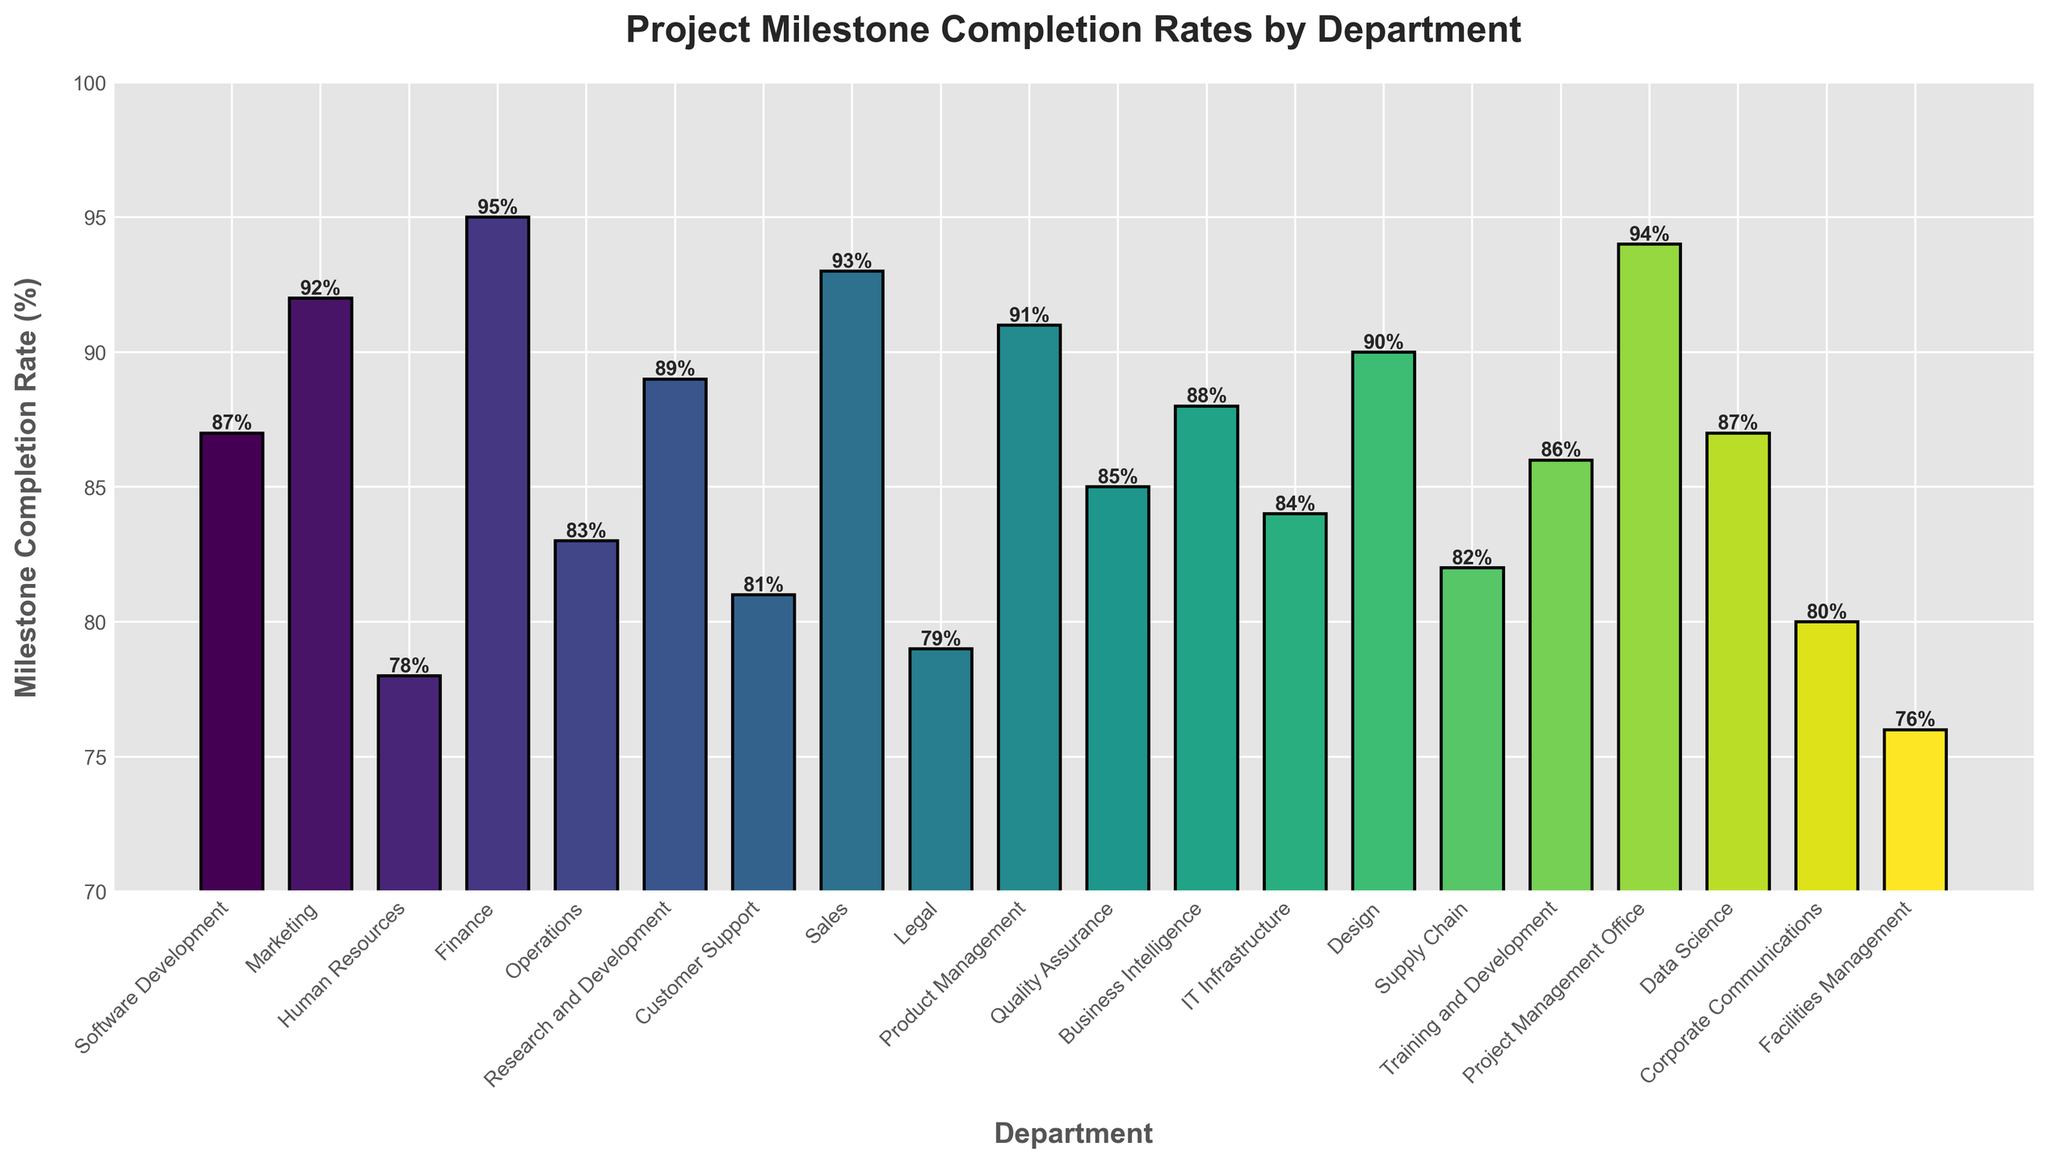What's the highest milestone completion rate? To determine the highest milestone completion rate, scan through all the bars and find the maximum value. The Finance department has the highest completion rate at 95%.
Answer: 95% Which departments have a milestone completion rate above 90%? Identify and list bars with a milestone completion rate greater than 90%. The departments are Marketing (92%), Finance (95%), Sales (93%), Product Management (91%), and Project Management Office (94%).
Answer: Marketing, Finance, Sales, Product Management, Project Management Office Which department has the lowest milestone completion rate, and what is it? To find the department with the lowest milestone completion rate, locate the shortest bar. Facilities Management has the lowest completion rate at 76%.
Answer: Facilities Management, 76% What's the average milestone completion rate across all departments? Add up the milestone completion rates for all departments and divide by the number of departments. (87+92+78+95+83+89+81+93+79+91+85+88+84+90+82+86+94+87+80+76)/20 = 86.05.
Answer: 86.05% How does the milestone completion rate of Sales compare to that of Marketing? Identify the bars for Sales and Marketing, then compare their heights. Sales has a completion rate of 93%, and Marketing has 92%. Sales is higher by 1%.
Answer: Sales is higher by 1% Which departments have a milestone completion rate between 80% and 85%? Identify bars that fall between 80% and 85%. The departments are Customer Support (81%), Legal (79%), IT Infrastructure (84%), and Supply Chain (82%).
Answer: Customer Support, IT Infrastructure, Supply Chain What is the difference in completion rate between Software Development and Human Resources? Find and subtract the completion rate of Human Resources from Software Development. 87% - 78% = 9%.
Answer: 9% Considering the departments with milestone completion rates below 80%, how many are there, and which ones are they? Identify and count the bars with completion rates below 80%. There are three departments: Human Resources (78%), Legal (79%), and Facilities Management (76%).
Answer: 3, Human Resources, Legal, Facilities Management What's the median milestone completion rate? Arrange the milestone completion rates in ascending order and find the middle value. The rates are: 76, 78, 79, 80, 81, 82, 83, 84, 85, 86, 87, 87, 88, 89, 90, 91, 92, 93, 94, 95. Median is average of 10th and 11th values: (86 + 87) / 2 = 86.5.
Answer: 86.5 Which department has a milestone completion rate closest to the average rate? First, calculate the average rate: 86.05%. Then, find the department whose rate is closest to this value. The Software Development, Business Intelligence, and Data Science departments are closest with a completion rate of 87%.
Answer: Software Development, Business Intelligence, Data Science 